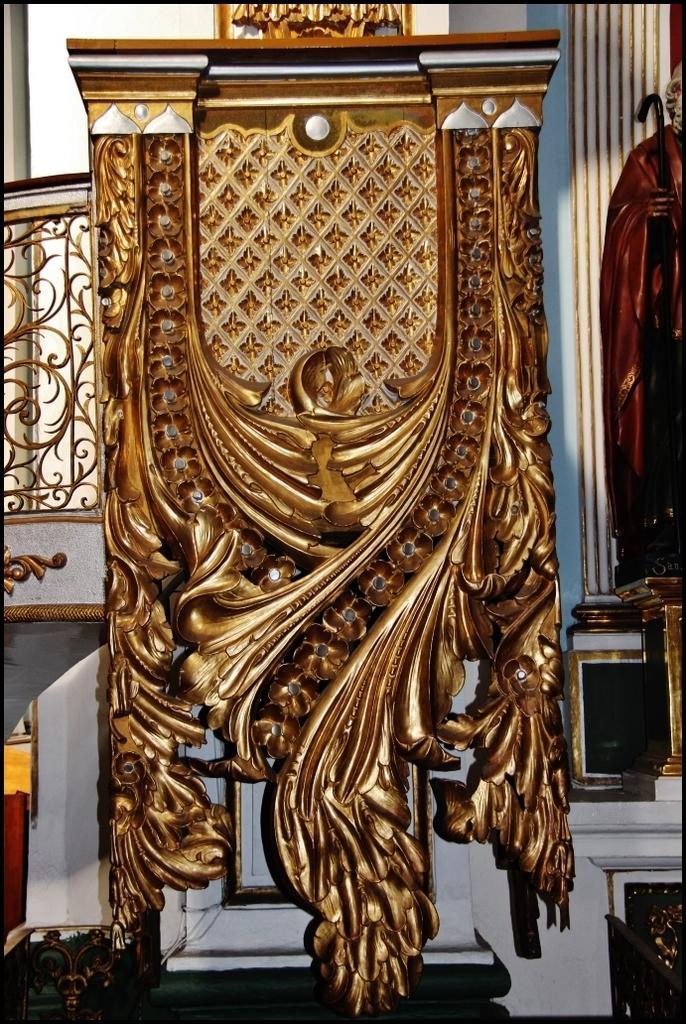Please provide a concise description of this image. In this image it looks like a building. And there is a wall with a design. And there is a light. At the side, it looks like a statue and holding a stick. And there is a fence. 